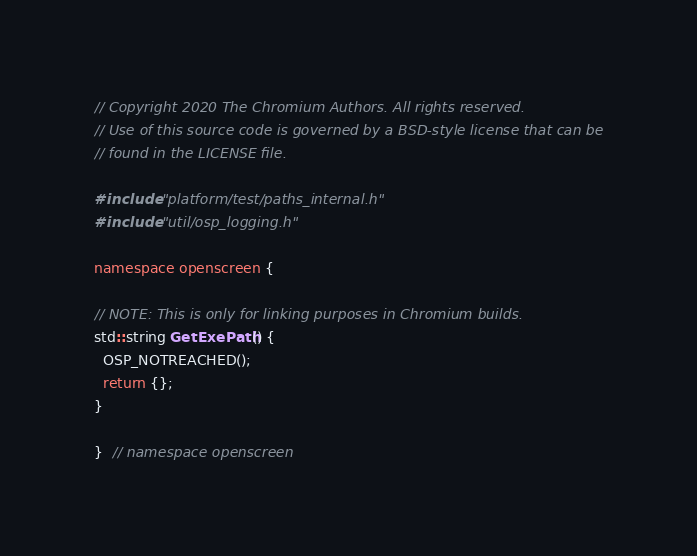<code> <loc_0><loc_0><loc_500><loc_500><_C++_>// Copyright 2020 The Chromium Authors. All rights reserved.
// Use of this source code is governed by a BSD-style license that can be
// found in the LICENSE file.

#include "platform/test/paths_internal.h"
#include "util/osp_logging.h"

namespace openscreen {

// NOTE: This is only for linking purposes in Chromium builds.
std::string GetExePath() {
  OSP_NOTREACHED();
  return {};
}

}  // namespace openscreen
</code> 